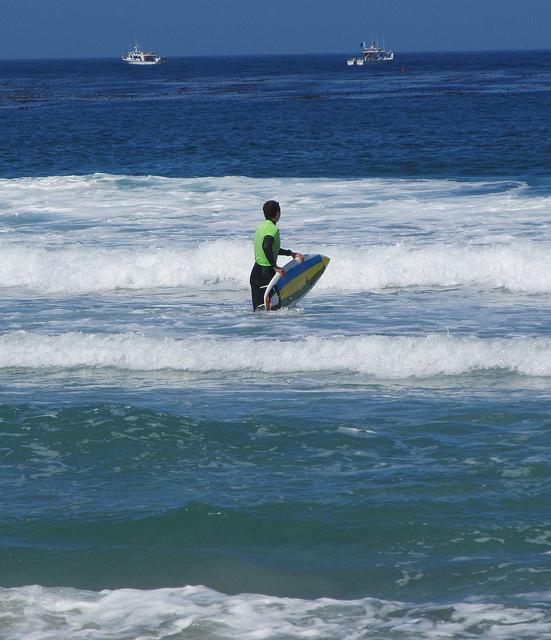What color is the man's shirt?
Be succinct. Green. What color is the man's board?
Answer briefly. Blue and yellow. How many boats are in the picture?
Keep it brief. 2. 